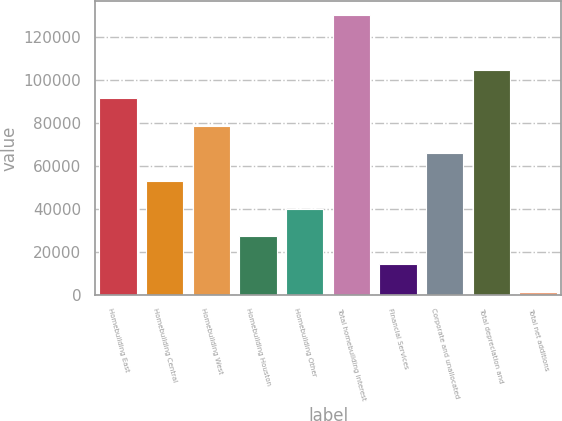Convert chart to OTSL. <chart><loc_0><loc_0><loc_500><loc_500><bar_chart><fcel>Homebuilding East<fcel>Homebuilding Central<fcel>Homebuilding West<fcel>Homebuilding Houston<fcel>Homebuilding Other<fcel>Total homebuilding interest<fcel>Financial Services<fcel>Corporate and unallocated<fcel>Total depreciation and<fcel>Total net additions<nl><fcel>91666.9<fcel>52976.8<fcel>78770.2<fcel>27183.4<fcel>40080.1<fcel>130357<fcel>14286.7<fcel>65873.5<fcel>104564<fcel>1390<nl></chart> 